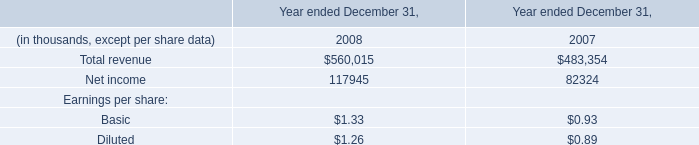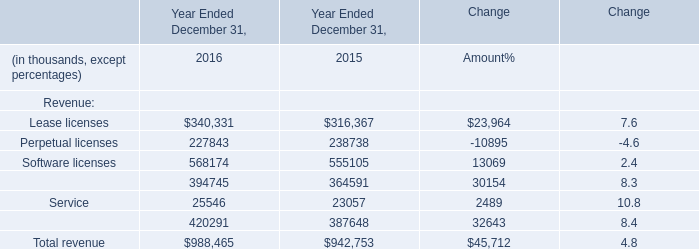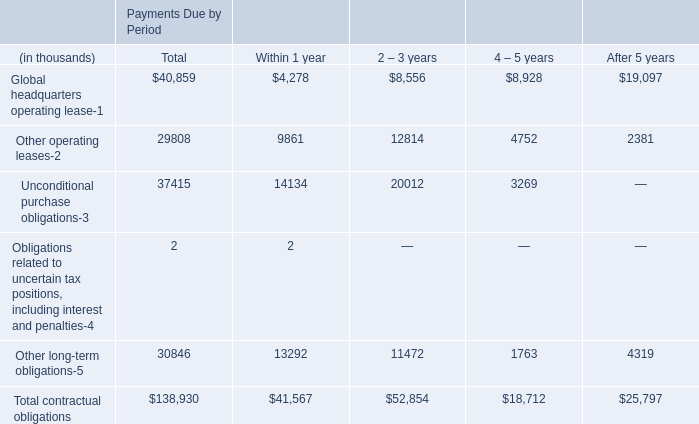What's the sum of Perpetual licenses of Year Ended December 31, 2015, and Net income of data 1 2007 ? 
Computations: (238738.0 + 82324.0)
Answer: 321062.0. 